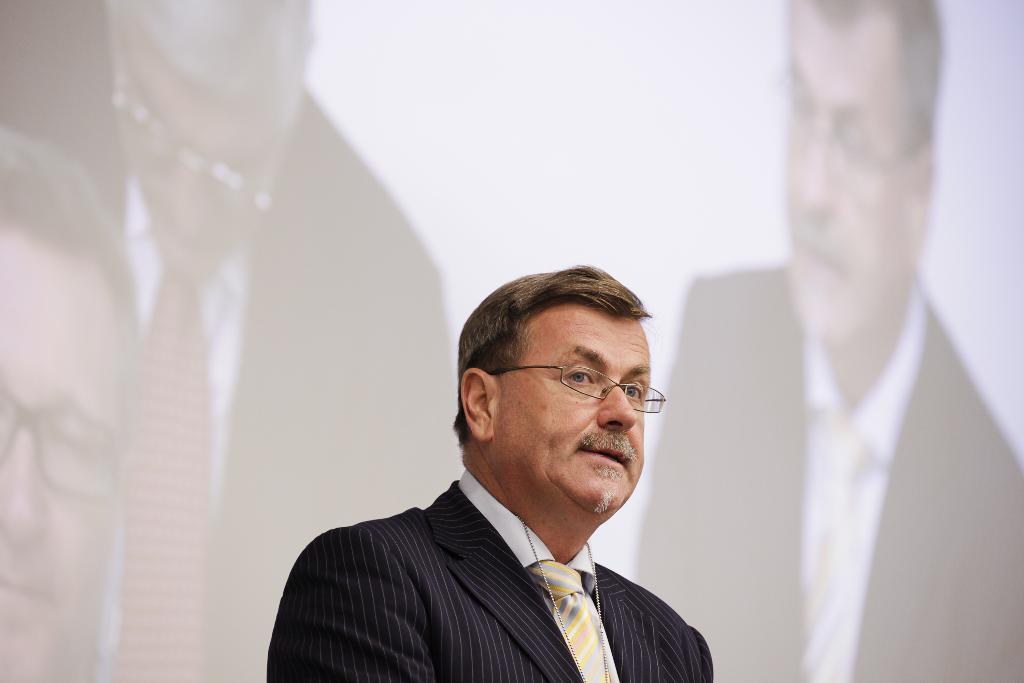Could you give a brief overview of what you see in this image? In this image there is a person wearing suit in the foreground. There is a screen in the background and we can see people on the screen. 